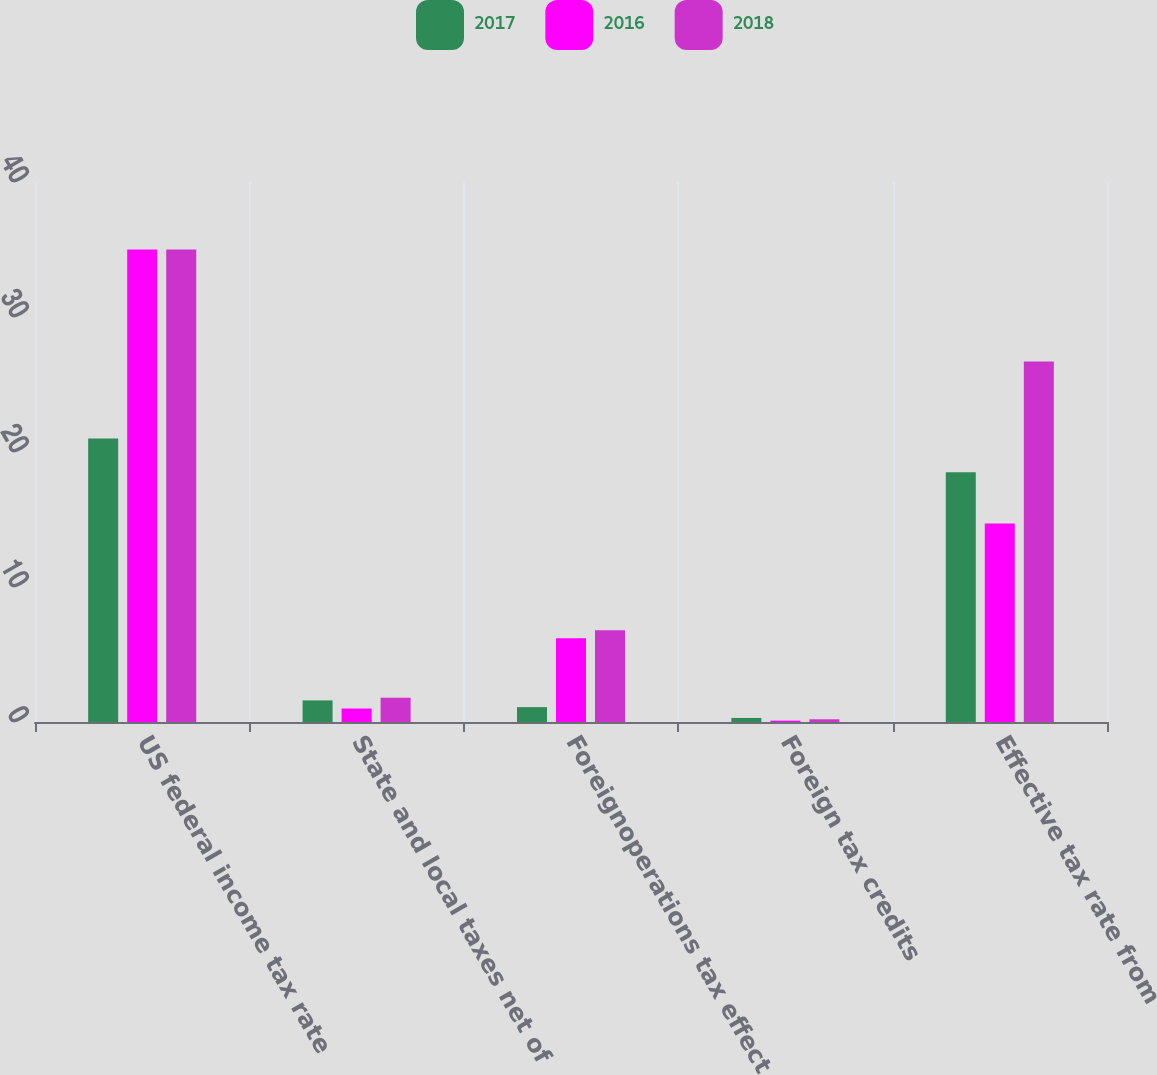Convert chart. <chart><loc_0><loc_0><loc_500><loc_500><stacked_bar_chart><ecel><fcel>US federal income tax rate<fcel>State and local taxes net of<fcel>Foreignoperations tax effect<fcel>Foreign tax credits<fcel>Effective tax rate from<nl><fcel>2017<fcel>21<fcel>1.6<fcel>1.1<fcel>0.3<fcel>18.5<nl><fcel>2016<fcel>35<fcel>1<fcel>6.2<fcel>0.1<fcel>14.7<nl><fcel>2018<fcel>35<fcel>1.8<fcel>6.8<fcel>0.2<fcel>26.7<nl></chart> 